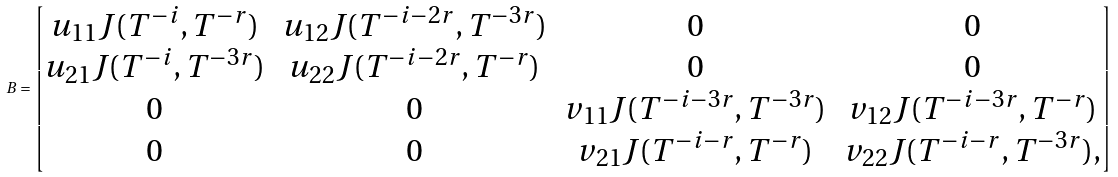Convert formula to latex. <formula><loc_0><loc_0><loc_500><loc_500>B = \begin{bmatrix} u _ { 1 1 } J ( T ^ { - i } , T ^ { - r } ) & u _ { 1 2 } J ( T ^ { - i - 2 r } , T ^ { - 3 r } ) & 0 & 0 \\ u _ { 2 1 } J ( T ^ { - i } , T ^ { - 3 r } ) & u _ { 2 2 } J ( T ^ { - i - 2 r } , T ^ { - r } ) & 0 & 0 \\ 0 & 0 & v _ { 1 1 } J ( T ^ { - i - 3 r } , T ^ { - 3 r } ) & v _ { 1 2 } J ( T ^ { - i - 3 r } , T ^ { - r } ) \\ 0 & 0 & v _ { 2 1 } J ( T ^ { - i - r } , T ^ { - r } ) & v _ { 2 2 } J ( T ^ { - i - r } , T ^ { - 3 r } ) , \end{bmatrix}</formula> 